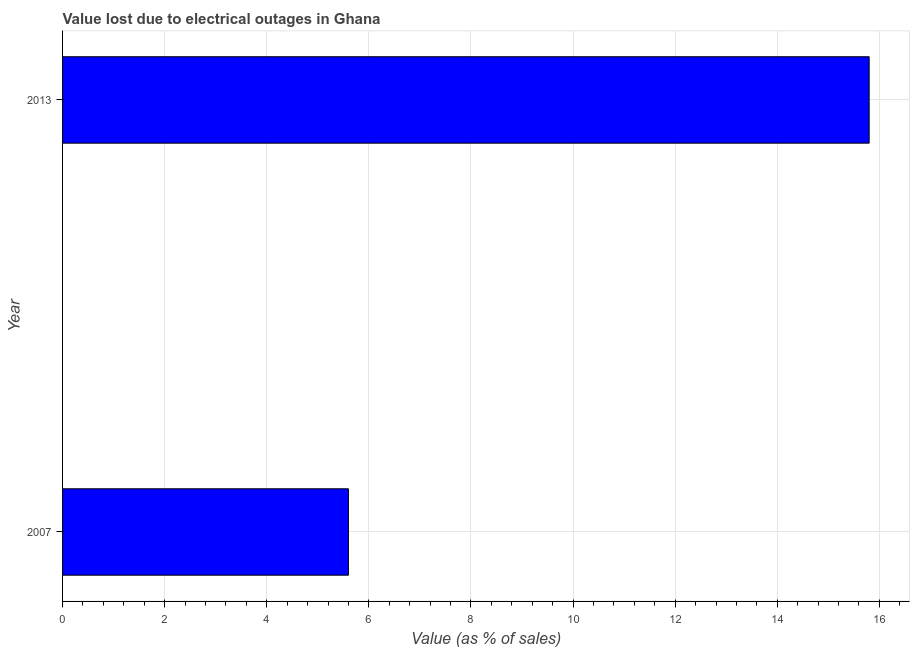Does the graph contain grids?
Offer a terse response. Yes. What is the title of the graph?
Give a very brief answer. Value lost due to electrical outages in Ghana. What is the label or title of the X-axis?
Your answer should be very brief. Value (as % of sales). What is the label or title of the Y-axis?
Provide a short and direct response. Year. Across all years, what is the maximum value lost due to electrical outages?
Offer a very short reply. 15.8. Across all years, what is the minimum value lost due to electrical outages?
Make the answer very short. 5.6. In which year was the value lost due to electrical outages minimum?
Keep it short and to the point. 2007. What is the sum of the value lost due to electrical outages?
Offer a very short reply. 21.4. What is the median value lost due to electrical outages?
Your answer should be very brief. 10.7. In how many years, is the value lost due to electrical outages greater than 5.2 %?
Your response must be concise. 2. Do a majority of the years between 2007 and 2013 (inclusive) have value lost due to electrical outages greater than 11.6 %?
Your answer should be very brief. No. What is the ratio of the value lost due to electrical outages in 2007 to that in 2013?
Give a very brief answer. 0.35. In how many years, is the value lost due to electrical outages greater than the average value lost due to electrical outages taken over all years?
Your answer should be very brief. 1. How many years are there in the graph?
Give a very brief answer. 2. What is the Value (as % of sales) of 2013?
Your answer should be very brief. 15.8. What is the difference between the Value (as % of sales) in 2007 and 2013?
Ensure brevity in your answer.  -10.2. What is the ratio of the Value (as % of sales) in 2007 to that in 2013?
Keep it short and to the point. 0.35. 